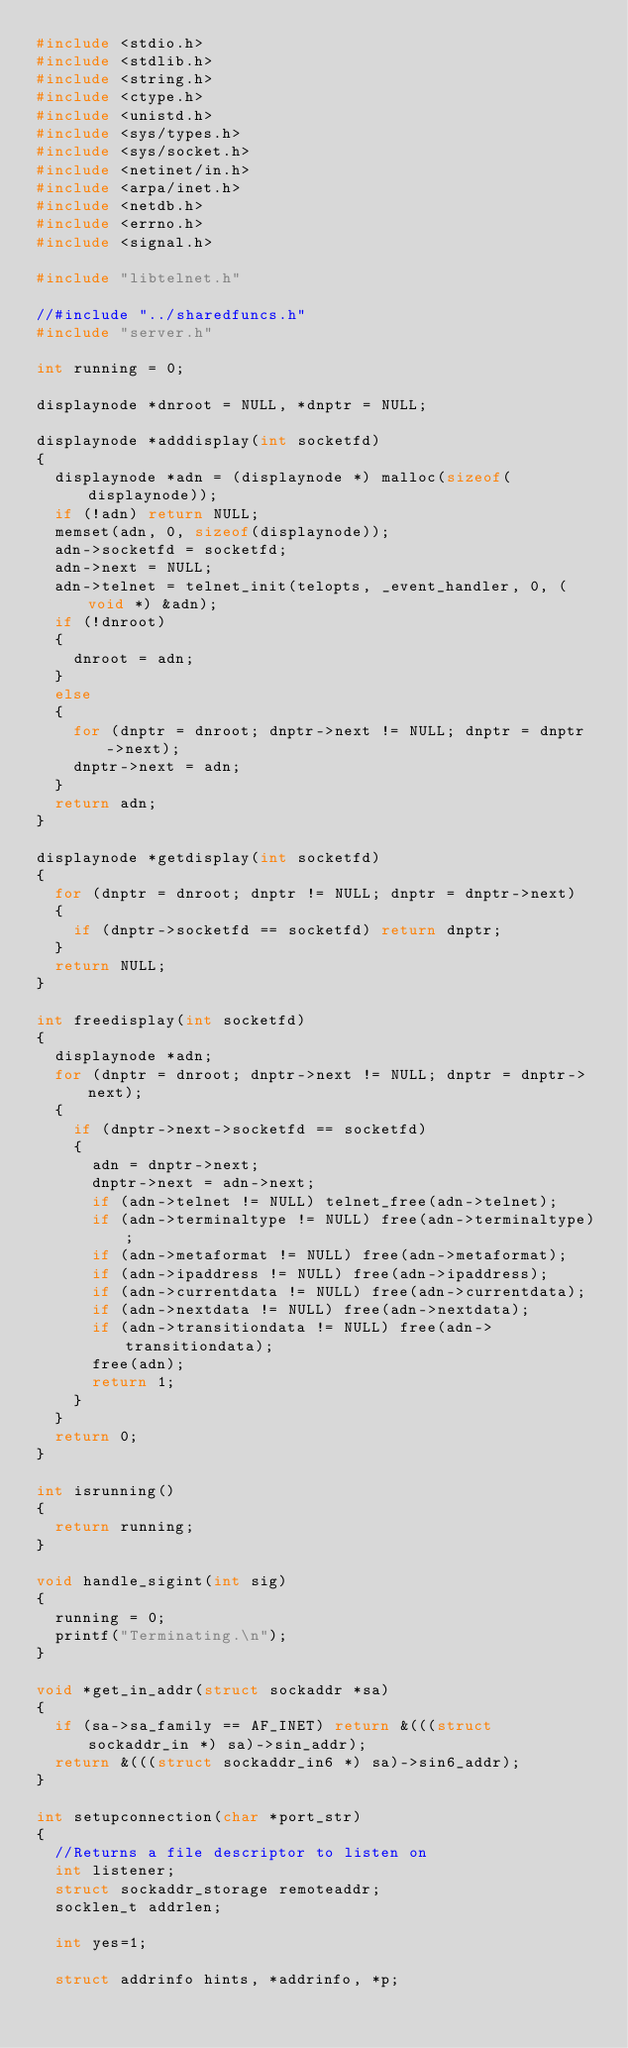Convert code to text. <code><loc_0><loc_0><loc_500><loc_500><_C_>#include <stdio.h>
#include <stdlib.h>
#include <string.h>
#include <ctype.h>
#include <unistd.h>
#include <sys/types.h>
#include <sys/socket.h>
#include <netinet/in.h>
#include <arpa/inet.h>
#include <netdb.h>
#include <errno.h>
#include <signal.h>

#include "libtelnet.h"

//#include "../sharedfuncs.h"
#include "server.h"

int running = 0;

displaynode *dnroot = NULL, *dnptr = NULL;

displaynode *adddisplay(int socketfd)
{
  displaynode *adn = (displaynode *) malloc(sizeof(displaynode));
  if (!adn) return NULL;
  memset(adn, 0, sizeof(displaynode));
  adn->socketfd = socketfd;
  adn->next = NULL;
  adn->telnet = telnet_init(telopts, _event_handler, 0, (void *) &adn);
  if (!dnroot)
  {
    dnroot = adn;
  }
  else
  {
    for (dnptr = dnroot; dnptr->next != NULL; dnptr = dnptr->next);
    dnptr->next = adn;
  }
  return adn;
}

displaynode *getdisplay(int socketfd)
{
  for (dnptr = dnroot; dnptr != NULL; dnptr = dnptr->next)
  {
    if (dnptr->socketfd == socketfd) return dnptr;
  }
  return NULL;
}

int freedisplay(int socketfd)
{
  displaynode *adn;
  for (dnptr = dnroot; dnptr->next != NULL; dnptr = dnptr->next);
  {
    if (dnptr->next->socketfd == socketfd)
    {
      adn = dnptr->next;
      dnptr->next = adn->next;
      if (adn->telnet != NULL) telnet_free(adn->telnet);
      if (adn->terminaltype != NULL) free(adn->terminaltype);
      if (adn->metaformat != NULL) free(adn->metaformat);
      if (adn->ipaddress != NULL) free(adn->ipaddress);
      if (adn->currentdata != NULL) free(adn->currentdata);
      if (adn->nextdata != NULL) free(adn->nextdata);
      if (adn->transitiondata != NULL) free(adn->transitiondata);
      free(adn);
      return 1;
    }
  }
  return 0;
}

int isrunning()
{
  return running;
}

void handle_sigint(int sig)
{
  running = 0;
  printf("Terminating.\n");
}

void *get_in_addr(struct sockaddr *sa)
{
  if (sa->sa_family == AF_INET) return &(((struct sockaddr_in *) sa)->sin_addr);
  return &(((struct sockaddr_in6 *) sa)->sin6_addr);
}

int setupconnection(char *port_str)
{
  //Returns a file descriptor to listen on
  int listener;
  struct sockaddr_storage remoteaddr;
  socklen_t addrlen;
  
  int yes=1;
  
  struct addrinfo hints, *addrinfo, *p;</code> 